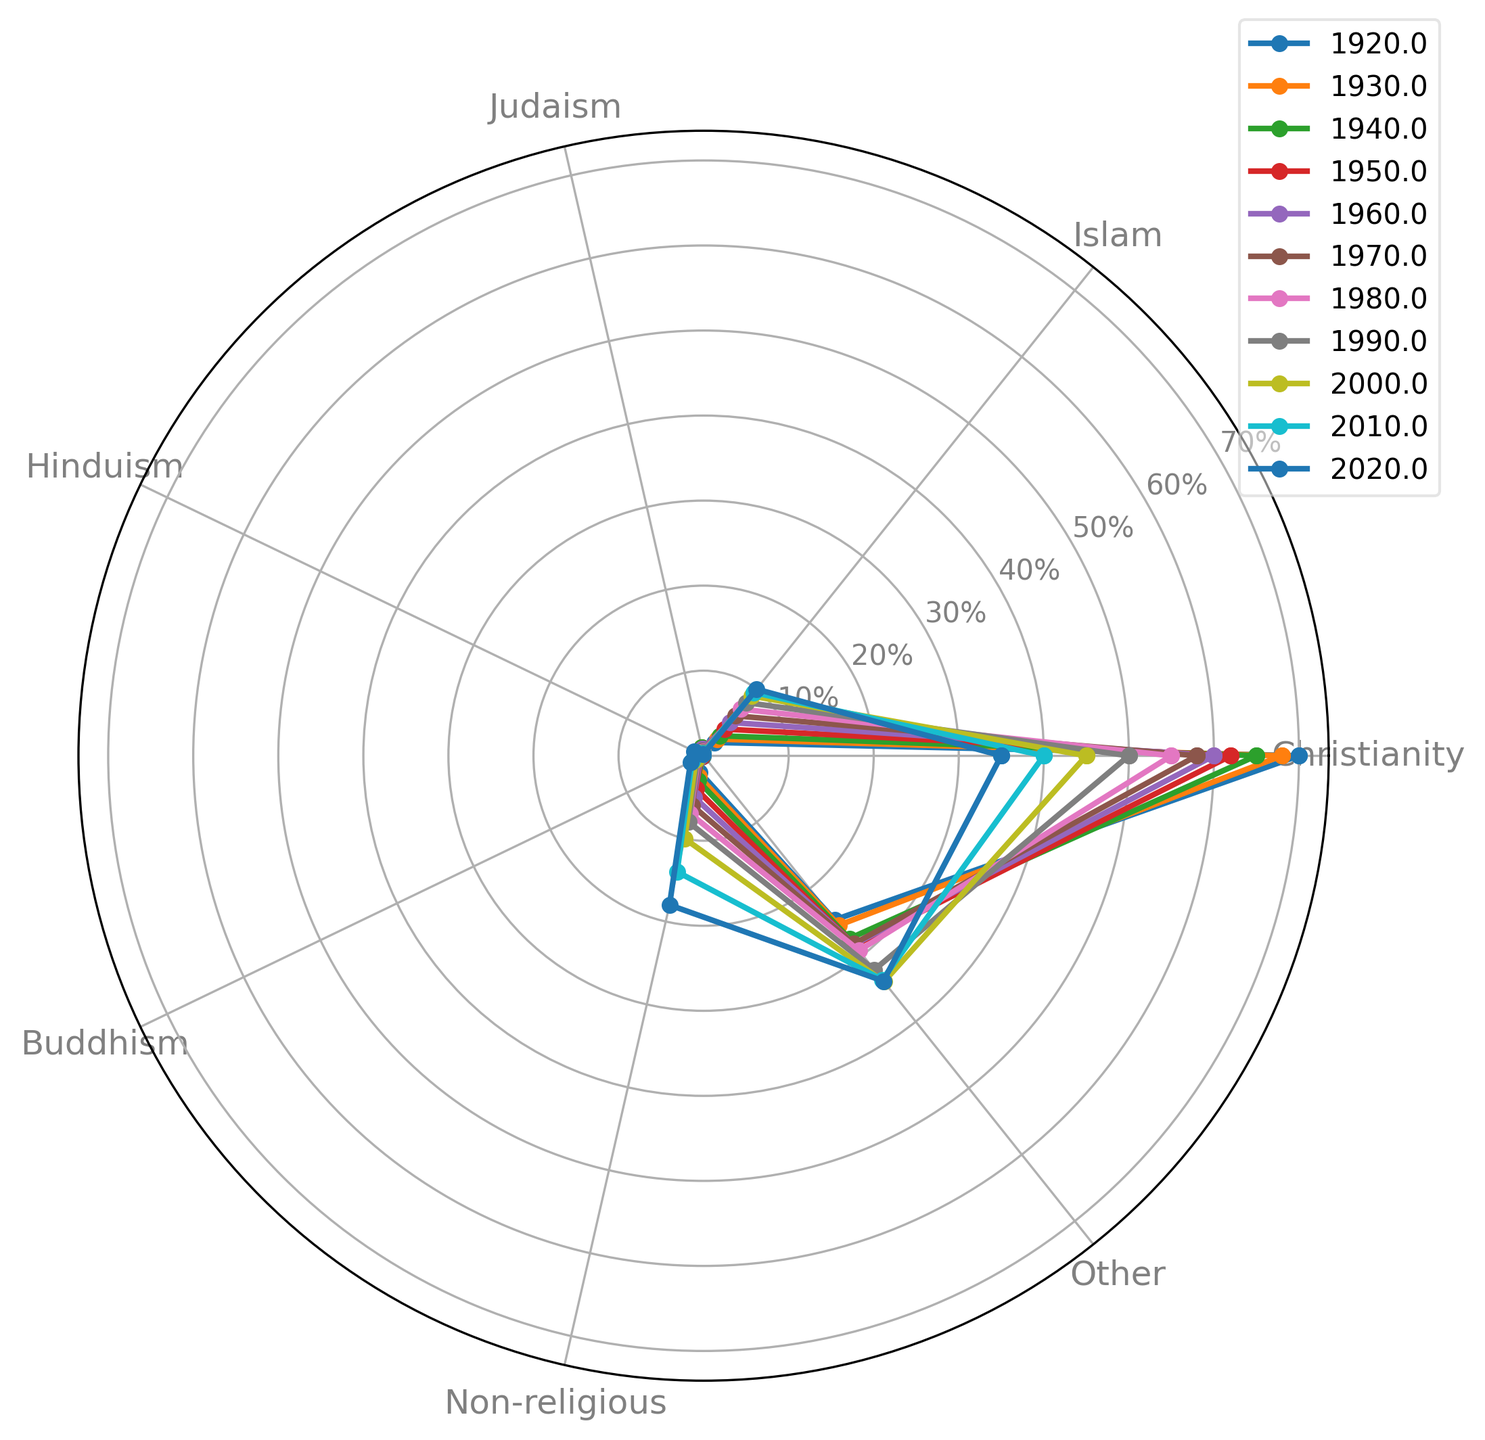What's the trend in the proportion of Non-religious individuals from 1920 to 2020? To identify the trend, we look at the positions of the Non-religious values over time on the radar chart. The proportions increased steadily from 2% in 1920 to 18% in 2020. This indicates a consistent rise in the number of Non-religious individuals.
Answer: The proportion increased steadily Which religion had the highest increase in proportion from 1920 to 2020? To find this, subtract the 1920 value from the 2020 value for each religion and compare the differences. Christianity decreased, while all others increased to varying degrees. Islam had the highest increase, from 2% to 10%, an 8% rise.
Answer: Islam Between 1950 and 2000, how did the proportion of Judaism change? By comparing the values at 1950 and 2000 on the radar chart, we see Judaism decreased from 0.8% to 0.3%. To calculate the change: 0.8% - 0.3% = 0.5%.
Answer: Decreased by 0.5% How did the proportion of Buddhism compare to that of Hinduism in 2020? Look at the 2020 values for both Buddhism (1.7%) and Hinduism (1.2%) on the radar chart. Buddhism is higher than Hinduism.
Answer: Buddhism is higher Which year shows the lowest proportion of Christianity, and what is that proportion? Scan the values for Christianity across all years. The lowest proportion is in 2020, where it is 35%.
Answer: 2020 with 35% In which decade did the proportion of Islam surpass 5%? Check the radar chart for Islam values. In the 1960s, Islam was at 5%, and in the 1970s, it increased to 6% – so it surpassed 5% in 1970.
Answer: 1970 What is the proportional difference between Christianity and Non-religious individuals in 2020? Look at the values for Christianity (35%) and Non-religious (18%) in 2020. Subtract Non-religious from Christianity: 35% - 18% = 17%.
Answer: 17% Considering the whole century, in which religion is there a constant and notable increase every decade? Analyzing the values across each decade on the radar chart reveals that Islam has shown a constant and notable increase every decade from 1920 to 2020.
Answer: Islam By how much did the proportion of people in the 'Other' category change from 1940 to 1980? Compare 1940 (27.5%) and 1980 (29.3%) values for 'Other.' Calculate the difference: 29.3% - 27.5% = 1.8%.
Answer: Increased by 1.8% What was the proportion of Hinduism in 2000 and how did it change compared to 1940? The 2000 value for Hinduism is 0.7% and the 1940 value is 0.3%. Calculate the change: 0.7% - 0.3% = 0.4%.
Answer: Increased by 0.4% 